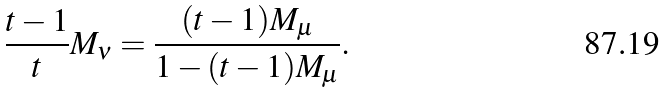<formula> <loc_0><loc_0><loc_500><loc_500>\frac { t - 1 } { t } M _ { \nu } = \frac { ( t - 1 ) M _ { \mu } } { 1 - ( t - 1 ) M _ { \mu } } .</formula> 